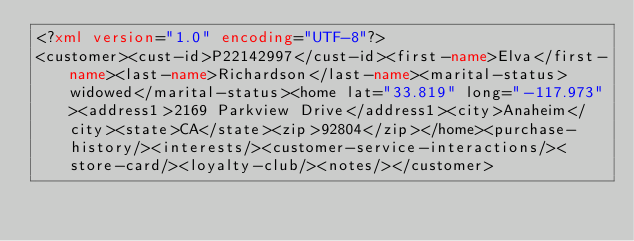<code> <loc_0><loc_0><loc_500><loc_500><_XML_><?xml version="1.0" encoding="UTF-8"?>
<customer><cust-id>P22142997</cust-id><first-name>Elva</first-name><last-name>Richardson</last-name><marital-status>widowed</marital-status><home lat="33.819" long="-117.973"><address1>2169 Parkview Drive</address1><city>Anaheim</city><state>CA</state><zip>92804</zip></home><purchase-history/><interests/><customer-service-interactions/><store-card/><loyalty-club/><notes/></customer></code> 